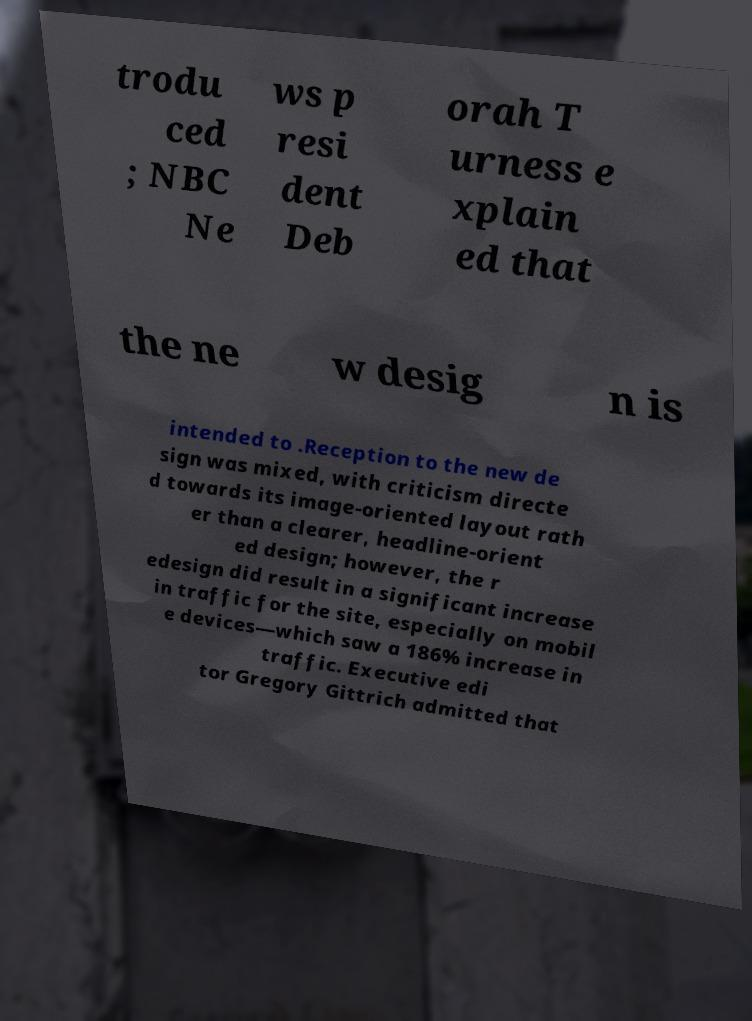Please read and relay the text visible in this image. What does it say? trodu ced ; NBC Ne ws p resi dent Deb orah T urness e xplain ed that the ne w desig n is intended to .Reception to the new de sign was mixed, with criticism directe d towards its image-oriented layout rath er than a clearer, headline-orient ed design; however, the r edesign did result in a significant increase in traffic for the site, especially on mobil e devices—which saw a 186% increase in traffic. Executive edi tor Gregory Gittrich admitted that 